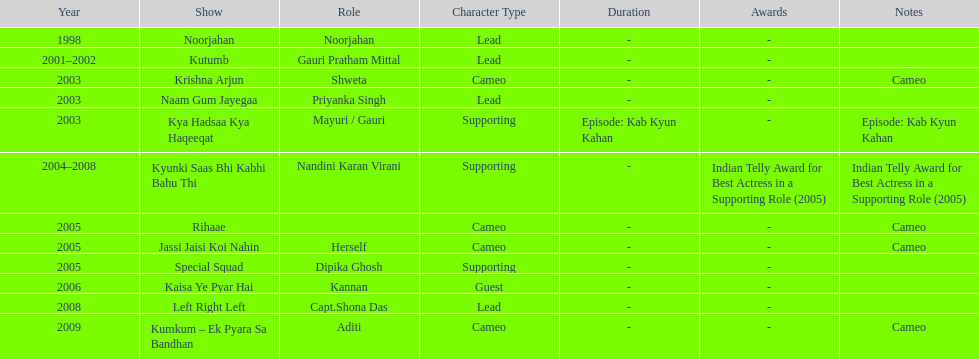Write the full table. {'header': ['Year', 'Show', 'Role', 'Character Type', 'Duration', 'Awards', 'Notes'], 'rows': [['1998', 'Noorjahan', 'Noorjahan', 'Lead', '-', '-', ''], ['2001–2002', 'Kutumb', 'Gauri Pratham Mittal', 'Lead', '-', '-', ''], ['2003', 'Krishna Arjun', 'Shweta', 'Cameo', '-', '-', 'Cameo'], ['2003', 'Naam Gum Jayegaa', 'Priyanka Singh', 'Lead', '-', '-', ''], ['2003', 'Kya Hadsaa Kya Haqeeqat', 'Mayuri / Gauri', 'Supporting', 'Episode: Kab Kyun Kahan', '-', 'Episode: Kab Kyun Kahan'], ['2004–2008', 'Kyunki Saas Bhi Kabhi Bahu Thi', 'Nandini Karan Virani', 'Supporting', '-', 'Indian Telly Award for Best Actress in a Supporting Role (2005)', 'Indian Telly Award for Best Actress in a Supporting Role (2005)'], ['2005', 'Rihaae', '', 'Cameo', '-', '-', 'Cameo'], ['2005', 'Jassi Jaisi Koi Nahin', 'Herself', 'Cameo', '-', '-', 'Cameo'], ['2005', 'Special Squad', 'Dipika Ghosh', 'Supporting', '-', '-', ''], ['2006', 'Kaisa Ye Pyar Hai', 'Kannan', 'Guest', '-', '-', ''], ['2008', 'Left Right Left', 'Capt.Shona Das', 'Lead', '-', '-', ''], ['2009', 'Kumkum – Ek Pyara Sa Bandhan', 'Aditi', 'Cameo', '-', '-', 'Cameo']]} Which television show was gauri in for the longest amount of time? Kyunki Saas Bhi Kabhi Bahu Thi. 